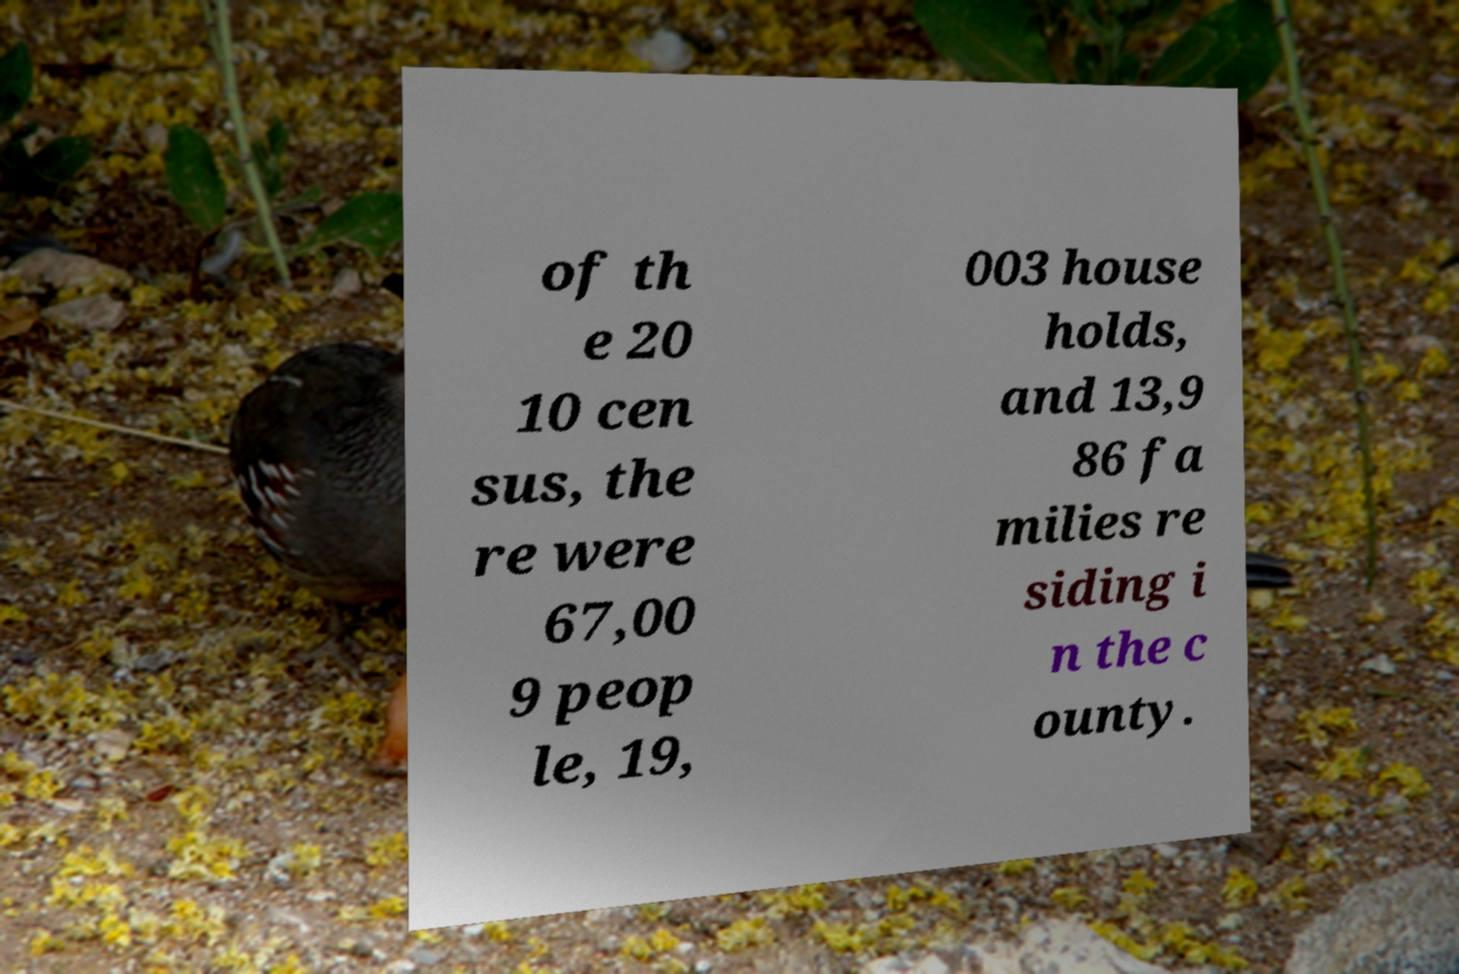Can you read and provide the text displayed in the image?This photo seems to have some interesting text. Can you extract and type it out for me? of th e 20 10 cen sus, the re were 67,00 9 peop le, 19, 003 house holds, and 13,9 86 fa milies re siding i n the c ounty. 